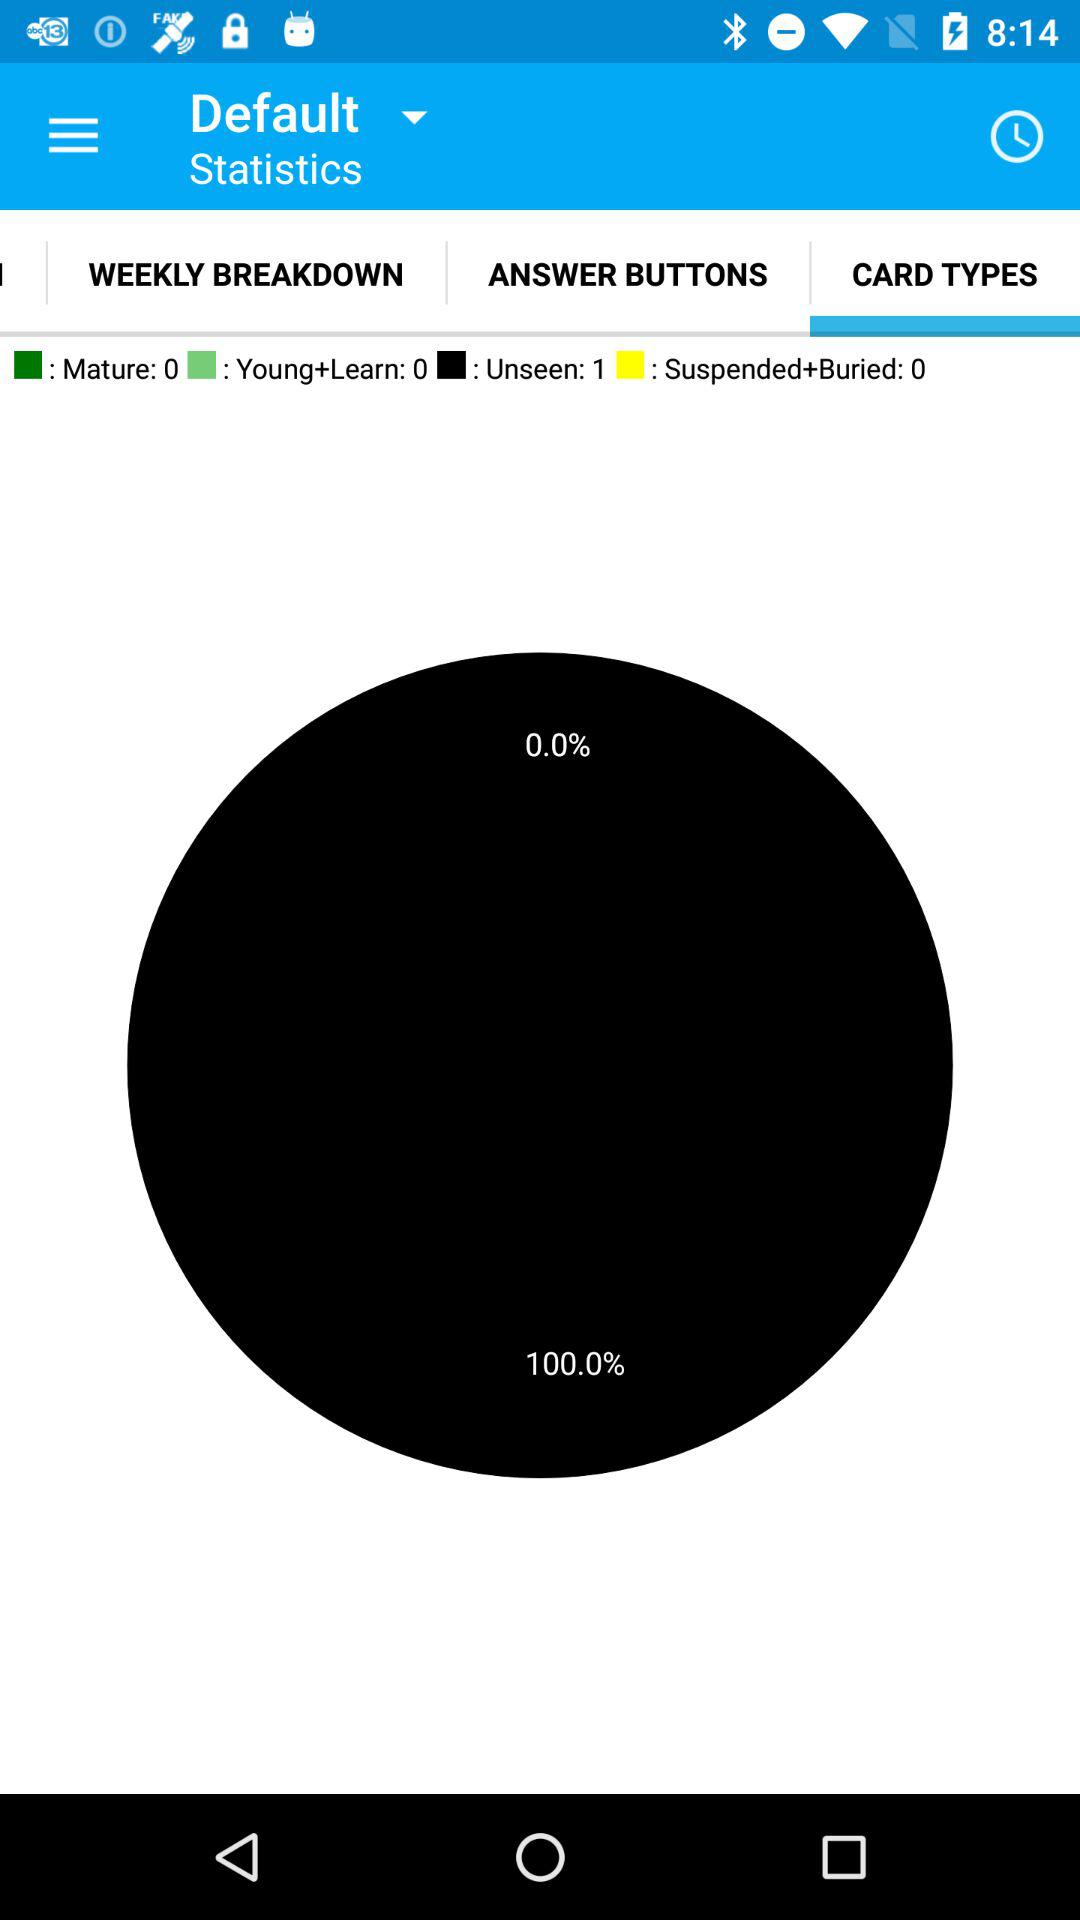Which tab is selected? The selected tab is "Card Types". 